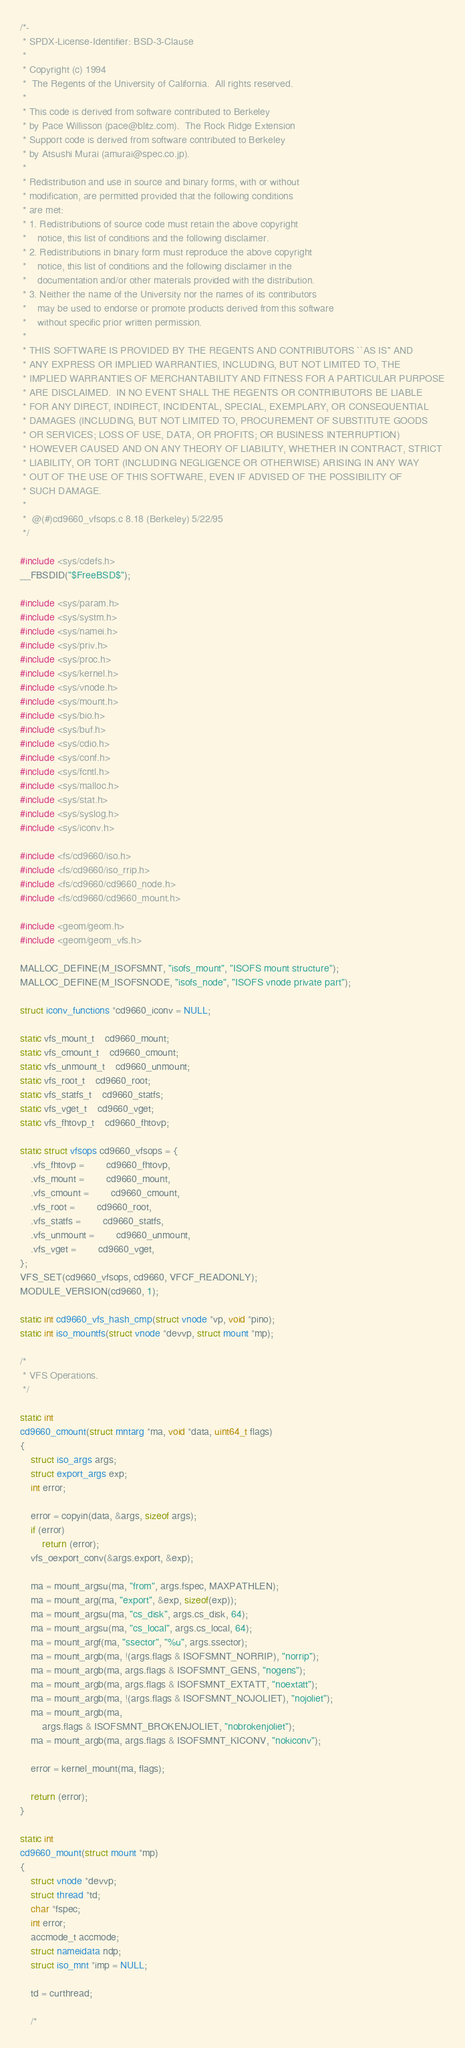<code> <loc_0><loc_0><loc_500><loc_500><_C_>/*-
 * SPDX-License-Identifier: BSD-3-Clause
 *
 * Copyright (c) 1994
 *	The Regents of the University of California.  All rights reserved.
 *
 * This code is derived from software contributed to Berkeley
 * by Pace Willisson (pace@blitz.com).  The Rock Ridge Extension
 * Support code is derived from software contributed to Berkeley
 * by Atsushi Murai (amurai@spec.co.jp).
 *
 * Redistribution and use in source and binary forms, with or without
 * modification, are permitted provided that the following conditions
 * are met:
 * 1. Redistributions of source code must retain the above copyright
 *    notice, this list of conditions and the following disclaimer.
 * 2. Redistributions in binary form must reproduce the above copyright
 *    notice, this list of conditions and the following disclaimer in the
 *    documentation and/or other materials provided with the distribution.
 * 3. Neither the name of the University nor the names of its contributors
 *    may be used to endorse or promote products derived from this software
 *    without specific prior written permission.
 *
 * THIS SOFTWARE IS PROVIDED BY THE REGENTS AND CONTRIBUTORS ``AS IS'' AND
 * ANY EXPRESS OR IMPLIED WARRANTIES, INCLUDING, BUT NOT LIMITED TO, THE
 * IMPLIED WARRANTIES OF MERCHANTABILITY AND FITNESS FOR A PARTICULAR PURPOSE
 * ARE DISCLAIMED.  IN NO EVENT SHALL THE REGENTS OR CONTRIBUTORS BE LIABLE
 * FOR ANY DIRECT, INDIRECT, INCIDENTAL, SPECIAL, EXEMPLARY, OR CONSEQUENTIAL
 * DAMAGES (INCLUDING, BUT NOT LIMITED TO, PROCUREMENT OF SUBSTITUTE GOODS
 * OR SERVICES; LOSS OF USE, DATA, OR PROFITS; OR BUSINESS INTERRUPTION)
 * HOWEVER CAUSED AND ON ANY THEORY OF LIABILITY, WHETHER IN CONTRACT, STRICT
 * LIABILITY, OR TORT (INCLUDING NEGLIGENCE OR OTHERWISE) ARISING IN ANY WAY
 * OUT OF THE USE OF THIS SOFTWARE, EVEN IF ADVISED OF THE POSSIBILITY OF
 * SUCH DAMAGE.
 *
 *	@(#)cd9660_vfsops.c	8.18 (Berkeley) 5/22/95
 */

#include <sys/cdefs.h>
__FBSDID("$FreeBSD$");

#include <sys/param.h>
#include <sys/systm.h>
#include <sys/namei.h>
#include <sys/priv.h>
#include <sys/proc.h>
#include <sys/kernel.h>
#include <sys/vnode.h>
#include <sys/mount.h>
#include <sys/bio.h>
#include <sys/buf.h>
#include <sys/cdio.h>
#include <sys/conf.h>
#include <sys/fcntl.h>
#include <sys/malloc.h>
#include <sys/stat.h>
#include <sys/syslog.h>
#include <sys/iconv.h>

#include <fs/cd9660/iso.h>
#include <fs/cd9660/iso_rrip.h>
#include <fs/cd9660/cd9660_node.h>
#include <fs/cd9660/cd9660_mount.h>

#include <geom/geom.h>
#include <geom/geom_vfs.h>

MALLOC_DEFINE(M_ISOFSMNT, "isofs_mount", "ISOFS mount structure");
MALLOC_DEFINE(M_ISOFSNODE, "isofs_node", "ISOFS vnode private part");

struct iconv_functions *cd9660_iconv = NULL;

static vfs_mount_t	cd9660_mount;
static vfs_cmount_t	cd9660_cmount;
static vfs_unmount_t	cd9660_unmount;
static vfs_root_t	cd9660_root;
static vfs_statfs_t	cd9660_statfs;
static vfs_vget_t	cd9660_vget;
static vfs_fhtovp_t	cd9660_fhtovp;

static struct vfsops cd9660_vfsops = {
	.vfs_fhtovp =		cd9660_fhtovp,
	.vfs_mount =		cd9660_mount,
	.vfs_cmount =		cd9660_cmount,
	.vfs_root =		cd9660_root,
	.vfs_statfs =		cd9660_statfs,
	.vfs_unmount =		cd9660_unmount,
	.vfs_vget =		cd9660_vget,
};
VFS_SET(cd9660_vfsops, cd9660, VFCF_READONLY);
MODULE_VERSION(cd9660, 1);

static int cd9660_vfs_hash_cmp(struct vnode *vp, void *pino);
static int iso_mountfs(struct vnode *devvp, struct mount *mp);

/*
 * VFS Operations.
 */

static int
cd9660_cmount(struct mntarg *ma, void *data, uint64_t flags)
{
	struct iso_args args;
	struct export_args exp;
	int error;

	error = copyin(data, &args, sizeof args);
	if (error)
		return (error);
	vfs_oexport_conv(&args.export, &exp);

	ma = mount_argsu(ma, "from", args.fspec, MAXPATHLEN);
	ma = mount_arg(ma, "export", &exp, sizeof(exp));
	ma = mount_argsu(ma, "cs_disk", args.cs_disk, 64);
	ma = mount_argsu(ma, "cs_local", args.cs_local, 64);
	ma = mount_argf(ma, "ssector", "%u", args.ssector);
	ma = mount_argb(ma, !(args.flags & ISOFSMNT_NORRIP), "norrip");
	ma = mount_argb(ma, args.flags & ISOFSMNT_GENS, "nogens");
	ma = mount_argb(ma, args.flags & ISOFSMNT_EXTATT, "noextatt");
	ma = mount_argb(ma, !(args.flags & ISOFSMNT_NOJOLIET), "nojoliet");
	ma = mount_argb(ma,
	    args.flags & ISOFSMNT_BROKENJOLIET, "nobrokenjoliet");
	ma = mount_argb(ma, args.flags & ISOFSMNT_KICONV, "nokiconv");

	error = kernel_mount(ma, flags);

	return (error);
}

static int
cd9660_mount(struct mount *mp)
{
	struct vnode *devvp;
	struct thread *td;
	char *fspec;
	int error;
	accmode_t accmode;
	struct nameidata ndp;
	struct iso_mnt *imp = NULL;

	td = curthread;

	/*</code> 